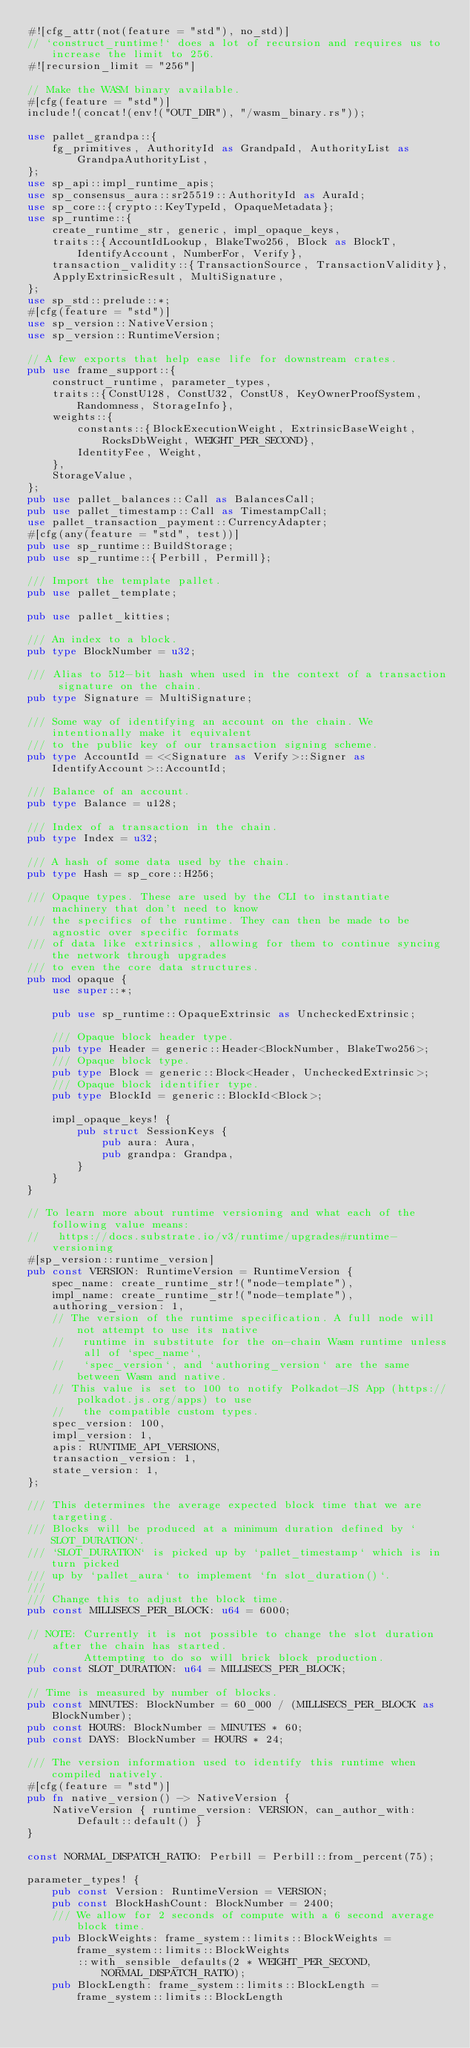Convert code to text. <code><loc_0><loc_0><loc_500><loc_500><_Rust_>#![cfg_attr(not(feature = "std"), no_std)]
// `construct_runtime!` does a lot of recursion and requires us to increase the limit to 256.
#![recursion_limit = "256"]

// Make the WASM binary available.
#[cfg(feature = "std")]
include!(concat!(env!("OUT_DIR"), "/wasm_binary.rs"));

use pallet_grandpa::{
	fg_primitives, AuthorityId as GrandpaId, AuthorityList as GrandpaAuthorityList,
};
use sp_api::impl_runtime_apis;
use sp_consensus_aura::sr25519::AuthorityId as AuraId;
use sp_core::{crypto::KeyTypeId, OpaqueMetadata};
use sp_runtime::{
	create_runtime_str, generic, impl_opaque_keys,
	traits::{AccountIdLookup, BlakeTwo256, Block as BlockT, IdentifyAccount, NumberFor, Verify},
	transaction_validity::{TransactionSource, TransactionValidity},
	ApplyExtrinsicResult, MultiSignature,
};
use sp_std::prelude::*;
#[cfg(feature = "std")]
use sp_version::NativeVersion;
use sp_version::RuntimeVersion;

// A few exports that help ease life for downstream crates.
pub use frame_support::{
	construct_runtime, parameter_types,
	traits::{ConstU128, ConstU32, ConstU8, KeyOwnerProofSystem, Randomness, StorageInfo},
	weights::{
		constants::{BlockExecutionWeight, ExtrinsicBaseWeight, RocksDbWeight, WEIGHT_PER_SECOND},
		IdentityFee, Weight,
	},
	StorageValue,
};
pub use pallet_balances::Call as BalancesCall;
pub use pallet_timestamp::Call as TimestampCall;
use pallet_transaction_payment::CurrencyAdapter;
#[cfg(any(feature = "std", test))]
pub use sp_runtime::BuildStorage;
pub use sp_runtime::{Perbill, Permill};

/// Import the template pallet.
pub use pallet_template;

pub use pallet_kitties;

/// An index to a block.
pub type BlockNumber = u32;

/// Alias to 512-bit hash when used in the context of a transaction signature on the chain.
pub type Signature = MultiSignature;

/// Some way of identifying an account on the chain. We intentionally make it equivalent
/// to the public key of our transaction signing scheme.
pub type AccountId = <<Signature as Verify>::Signer as IdentifyAccount>::AccountId;

/// Balance of an account.
pub type Balance = u128;

/// Index of a transaction in the chain.
pub type Index = u32;

/// A hash of some data used by the chain.
pub type Hash = sp_core::H256;

/// Opaque types. These are used by the CLI to instantiate machinery that don't need to know
/// the specifics of the runtime. They can then be made to be agnostic over specific formats
/// of data like extrinsics, allowing for them to continue syncing the network through upgrades
/// to even the core data structures.
pub mod opaque {
	use super::*;

	pub use sp_runtime::OpaqueExtrinsic as UncheckedExtrinsic;

	/// Opaque block header type.
	pub type Header = generic::Header<BlockNumber, BlakeTwo256>;
	/// Opaque block type.
	pub type Block = generic::Block<Header, UncheckedExtrinsic>;
	/// Opaque block identifier type.
	pub type BlockId = generic::BlockId<Block>;

	impl_opaque_keys! {
		pub struct SessionKeys {
			pub aura: Aura,
			pub grandpa: Grandpa,
		}
	}
}

// To learn more about runtime versioning and what each of the following value means:
//   https://docs.substrate.io/v3/runtime/upgrades#runtime-versioning
#[sp_version::runtime_version]
pub const VERSION: RuntimeVersion = RuntimeVersion {
	spec_name: create_runtime_str!("node-template"),
	impl_name: create_runtime_str!("node-template"),
	authoring_version: 1,
	// The version of the runtime specification. A full node will not attempt to use its native
	//   runtime in substitute for the on-chain Wasm runtime unless all of `spec_name`,
	//   `spec_version`, and `authoring_version` are the same between Wasm and native.
	// This value is set to 100 to notify Polkadot-JS App (https://polkadot.js.org/apps) to use
	//   the compatible custom types.
	spec_version: 100,
	impl_version: 1,
	apis: RUNTIME_API_VERSIONS,
	transaction_version: 1,
	state_version: 1,
};

/// This determines the average expected block time that we are targeting.
/// Blocks will be produced at a minimum duration defined by `SLOT_DURATION`.
/// `SLOT_DURATION` is picked up by `pallet_timestamp` which is in turn picked
/// up by `pallet_aura` to implement `fn slot_duration()`.
///
/// Change this to adjust the block time.
pub const MILLISECS_PER_BLOCK: u64 = 6000;

// NOTE: Currently it is not possible to change the slot duration after the chain has started.
//       Attempting to do so will brick block production.
pub const SLOT_DURATION: u64 = MILLISECS_PER_BLOCK;

// Time is measured by number of blocks.
pub const MINUTES: BlockNumber = 60_000 / (MILLISECS_PER_BLOCK as BlockNumber);
pub const HOURS: BlockNumber = MINUTES * 60;
pub const DAYS: BlockNumber = HOURS * 24;

/// The version information used to identify this runtime when compiled natively.
#[cfg(feature = "std")]
pub fn native_version() -> NativeVersion {
	NativeVersion { runtime_version: VERSION, can_author_with: Default::default() }
}

const NORMAL_DISPATCH_RATIO: Perbill = Perbill::from_percent(75);

parameter_types! {
	pub const Version: RuntimeVersion = VERSION;
	pub const BlockHashCount: BlockNumber = 2400;
	/// We allow for 2 seconds of compute with a 6 second average block time.
	pub BlockWeights: frame_system::limits::BlockWeights = frame_system::limits::BlockWeights
		::with_sensible_defaults(2 * WEIGHT_PER_SECOND, NORMAL_DISPATCH_RATIO);
	pub BlockLength: frame_system::limits::BlockLength = frame_system::limits::BlockLength</code> 